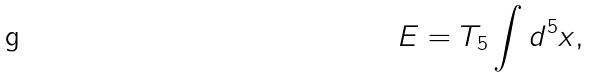Convert formula to latex. <formula><loc_0><loc_0><loc_500><loc_500>E = T _ { 5 } \int d ^ { 5 } x ,</formula> 